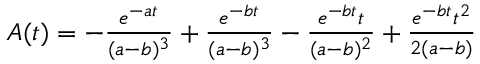Convert formula to latex. <formula><loc_0><loc_0><loc_500><loc_500>\begin{array} { c l l } { A ( t ) = - \frac { e ^ { - a t } } { ( a - b ) ^ { 3 } } + \frac { e ^ { - b t } } { ( a - b ) ^ { 3 } } - \frac { e ^ { - b t } t } { ( a - b ) ^ { 2 } } + \frac { e ^ { - b t } t ^ { 2 } } { 2 ( a - b ) } } \end{array}</formula> 